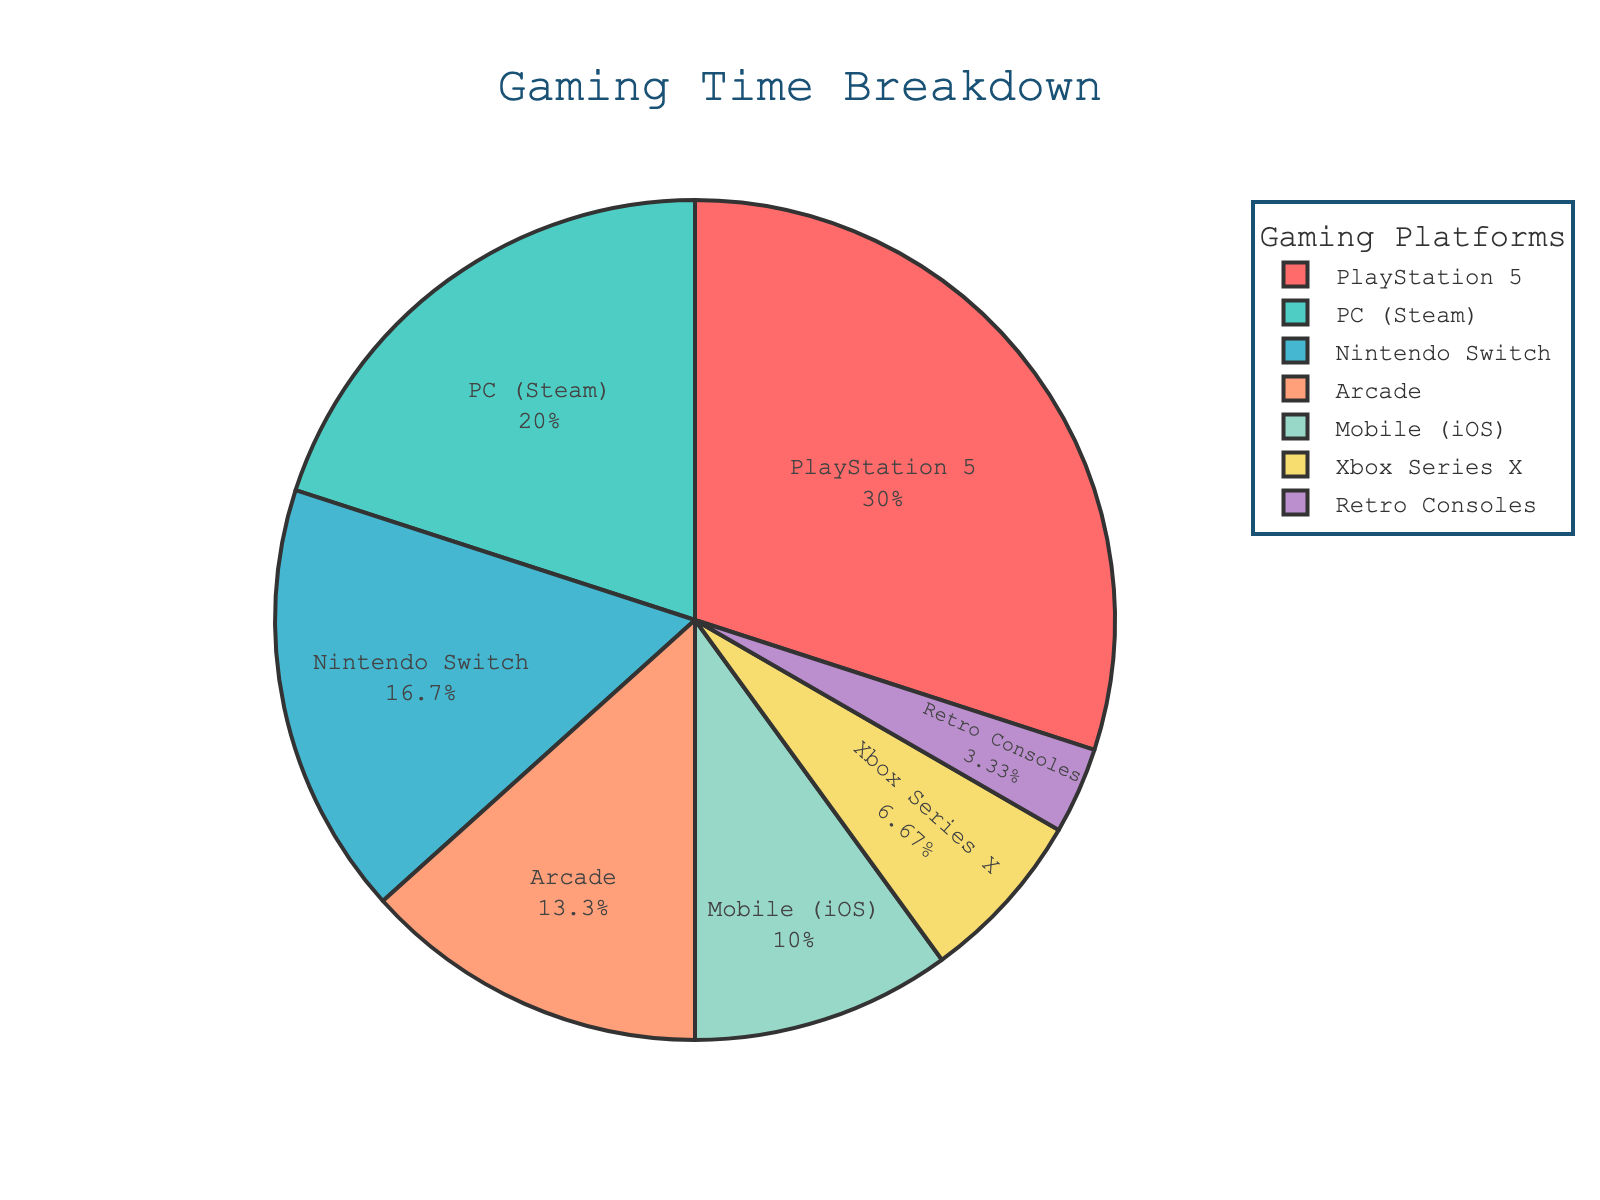What percentage of time is spent on PC (Steam) compared to the overall gaming time? To determine the percentage of time spent on PC (Steam), refer to the pie chart segment labeled "PC (Steam)". The percentage will be directly displayed on the pie chart. In this case, the chart shows 20%.
Answer: 20% Which gaming platform has the least amount of time spent? Look at the pie chart and identify the segment with the smallest size. The label for the smallest segment will indicate the platform with the least amount of time spent. Here, it is likely to be "Retro Consoles".
Answer: Retro Consoles What is the sum of hours spent on PlayStation 5 and Nintendo Switch? Add the hours spent on PlayStation 5 (45 hours) and Nintendo Switch (25 hours). The total is 45 + 25 = 70 hours.
Answer: 70 hours Which platform has more hours spent: Mobile (iOS) or Arcade? Compare the two segments labeled "Mobile (iOS)" and "Arcade". Mobile (iOS) has 15 hours while Arcade has 20 hours, so Arcade has more hours spent.
Answer: Arcade By how much do the hours spent on PlayStation 5 exceed those on Xbox Series X? Subtract the hours for Xbox Series X (10) from PlayStation 5 (45). The difference is 45 - 10 = 35 hours.
Answer: 35 hours What is the average time spent on Mobile (iOS), Arcade, and Xbox Series X? Sum the hours spent on Mobile (iOS) (15), Arcade (20), and Xbox Series X (10), then divide by the number of platforms (3). The average is (15 + 20 + 10) / 3 = 45 / 3 = 15 hours.
Answer: 15 hours Which gaming platform has the most time spent? Identify the largest segment in the pie chart, which will indicate the platform with the most time spent. This is the segment labeled "PlayStation 5".
Answer: PlayStation 5 How much combined gaming time is spent on platforms other than PlayStation 5 and PC (Steam)? Add the hours of all platforms except PlayStation 5 and PC (Steam): Nintendo Switch (25) + Mobile (iOS) (15) + Arcade (20) + Xbox Series X (10) + Retro Consoles (5). The total is 25 + 15 + 20 + 10 + 5 = 75 hours.
Answer: 75 hours What percentage of time is spent on Nintendo Switch compared to all other platforms combined? To find the percentage, divide the hours for Nintendo Switch (25) by the total hours for all other platforms (100 - 25 = 75) and multiply by 100. The percentage is (25 / 75) * 100 = 33.33%.
Answer: 33.33% Which platform's segment in the pie chart is displayed with a purple color? Based on the custom color palette provided in the code, identify which segment corresponds to the purple color by its order. Since the order is specified as PlayStation 5, PC (Steam), Nintendo Switch, Mobile (iOS), Arcade, Xbox Series X, Retro Consoles, the purple color corresponds to "Retro Consoles".
Answer: Retro Consoles 